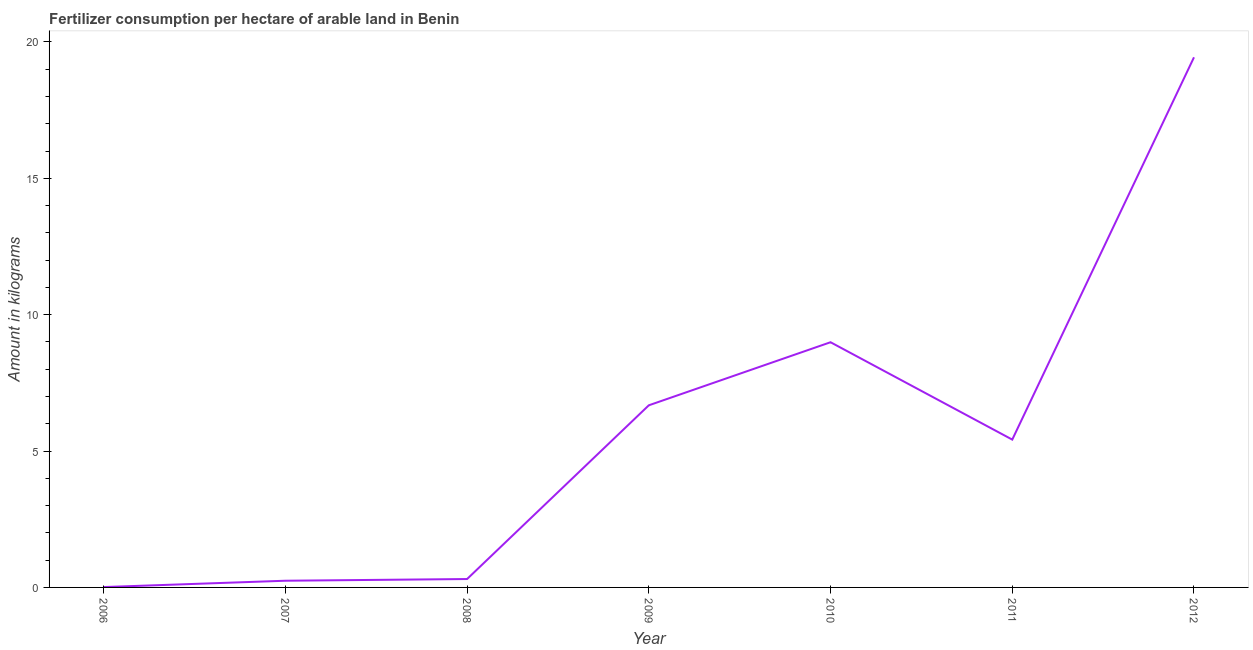What is the amount of fertilizer consumption in 2010?
Ensure brevity in your answer.  8.99. Across all years, what is the maximum amount of fertilizer consumption?
Offer a very short reply. 19.44. Across all years, what is the minimum amount of fertilizer consumption?
Offer a terse response. 0.01. In which year was the amount of fertilizer consumption maximum?
Keep it short and to the point. 2012. In which year was the amount of fertilizer consumption minimum?
Your answer should be very brief. 2006. What is the sum of the amount of fertilizer consumption?
Provide a succinct answer. 41.09. What is the difference between the amount of fertilizer consumption in 2007 and 2009?
Your answer should be compact. -6.43. What is the average amount of fertilizer consumption per year?
Provide a succinct answer. 5.87. What is the median amount of fertilizer consumption?
Offer a very short reply. 5.42. In how many years, is the amount of fertilizer consumption greater than 17 kg?
Your response must be concise. 1. What is the ratio of the amount of fertilizer consumption in 2009 to that in 2012?
Your answer should be compact. 0.34. Is the difference between the amount of fertilizer consumption in 2008 and 2011 greater than the difference between any two years?
Your response must be concise. No. What is the difference between the highest and the second highest amount of fertilizer consumption?
Your answer should be compact. 10.45. Is the sum of the amount of fertilizer consumption in 2010 and 2011 greater than the maximum amount of fertilizer consumption across all years?
Provide a short and direct response. No. What is the difference between the highest and the lowest amount of fertilizer consumption?
Provide a short and direct response. 19.42. Does the graph contain grids?
Offer a terse response. No. What is the title of the graph?
Make the answer very short. Fertilizer consumption per hectare of arable land in Benin . What is the label or title of the Y-axis?
Your answer should be very brief. Amount in kilograms. What is the Amount in kilograms of 2006?
Ensure brevity in your answer.  0.01. What is the Amount in kilograms in 2007?
Offer a very short reply. 0.25. What is the Amount in kilograms in 2008?
Offer a very short reply. 0.31. What is the Amount in kilograms in 2009?
Offer a terse response. 6.68. What is the Amount in kilograms in 2010?
Provide a succinct answer. 8.99. What is the Amount in kilograms of 2011?
Give a very brief answer. 5.42. What is the Amount in kilograms in 2012?
Offer a very short reply. 19.44. What is the difference between the Amount in kilograms in 2006 and 2007?
Keep it short and to the point. -0.23. What is the difference between the Amount in kilograms in 2006 and 2008?
Make the answer very short. -0.29. What is the difference between the Amount in kilograms in 2006 and 2009?
Offer a terse response. -6.66. What is the difference between the Amount in kilograms in 2006 and 2010?
Provide a succinct answer. -8.98. What is the difference between the Amount in kilograms in 2006 and 2011?
Offer a terse response. -5.41. What is the difference between the Amount in kilograms in 2006 and 2012?
Keep it short and to the point. -19.42. What is the difference between the Amount in kilograms in 2007 and 2008?
Provide a short and direct response. -0.06. What is the difference between the Amount in kilograms in 2007 and 2009?
Your answer should be very brief. -6.43. What is the difference between the Amount in kilograms in 2007 and 2010?
Your answer should be very brief. -8.74. What is the difference between the Amount in kilograms in 2007 and 2011?
Provide a short and direct response. -5.17. What is the difference between the Amount in kilograms in 2007 and 2012?
Your answer should be very brief. -19.19. What is the difference between the Amount in kilograms in 2008 and 2009?
Offer a very short reply. -6.37. What is the difference between the Amount in kilograms in 2008 and 2010?
Ensure brevity in your answer.  -8.68. What is the difference between the Amount in kilograms in 2008 and 2011?
Provide a short and direct response. -5.11. What is the difference between the Amount in kilograms in 2008 and 2012?
Offer a terse response. -19.13. What is the difference between the Amount in kilograms in 2009 and 2010?
Offer a terse response. -2.31. What is the difference between the Amount in kilograms in 2009 and 2011?
Give a very brief answer. 1.26. What is the difference between the Amount in kilograms in 2009 and 2012?
Give a very brief answer. -12.76. What is the difference between the Amount in kilograms in 2010 and 2011?
Ensure brevity in your answer.  3.57. What is the difference between the Amount in kilograms in 2010 and 2012?
Give a very brief answer. -10.45. What is the difference between the Amount in kilograms in 2011 and 2012?
Your answer should be compact. -14.02. What is the ratio of the Amount in kilograms in 2006 to that in 2007?
Ensure brevity in your answer.  0.05. What is the ratio of the Amount in kilograms in 2006 to that in 2008?
Ensure brevity in your answer.  0.04. What is the ratio of the Amount in kilograms in 2006 to that in 2009?
Ensure brevity in your answer.  0. What is the ratio of the Amount in kilograms in 2006 to that in 2011?
Your answer should be very brief. 0. What is the ratio of the Amount in kilograms in 2007 to that in 2008?
Make the answer very short. 0.8. What is the ratio of the Amount in kilograms in 2007 to that in 2009?
Offer a terse response. 0.04. What is the ratio of the Amount in kilograms in 2007 to that in 2010?
Your response must be concise. 0.03. What is the ratio of the Amount in kilograms in 2007 to that in 2011?
Offer a very short reply. 0.04. What is the ratio of the Amount in kilograms in 2007 to that in 2012?
Ensure brevity in your answer.  0.01. What is the ratio of the Amount in kilograms in 2008 to that in 2009?
Your answer should be very brief. 0.05. What is the ratio of the Amount in kilograms in 2008 to that in 2010?
Your answer should be compact. 0.03. What is the ratio of the Amount in kilograms in 2008 to that in 2011?
Provide a succinct answer. 0.06. What is the ratio of the Amount in kilograms in 2008 to that in 2012?
Make the answer very short. 0.02. What is the ratio of the Amount in kilograms in 2009 to that in 2010?
Provide a succinct answer. 0.74. What is the ratio of the Amount in kilograms in 2009 to that in 2011?
Your response must be concise. 1.23. What is the ratio of the Amount in kilograms in 2009 to that in 2012?
Ensure brevity in your answer.  0.34. What is the ratio of the Amount in kilograms in 2010 to that in 2011?
Give a very brief answer. 1.66. What is the ratio of the Amount in kilograms in 2010 to that in 2012?
Give a very brief answer. 0.46. What is the ratio of the Amount in kilograms in 2011 to that in 2012?
Offer a terse response. 0.28. 